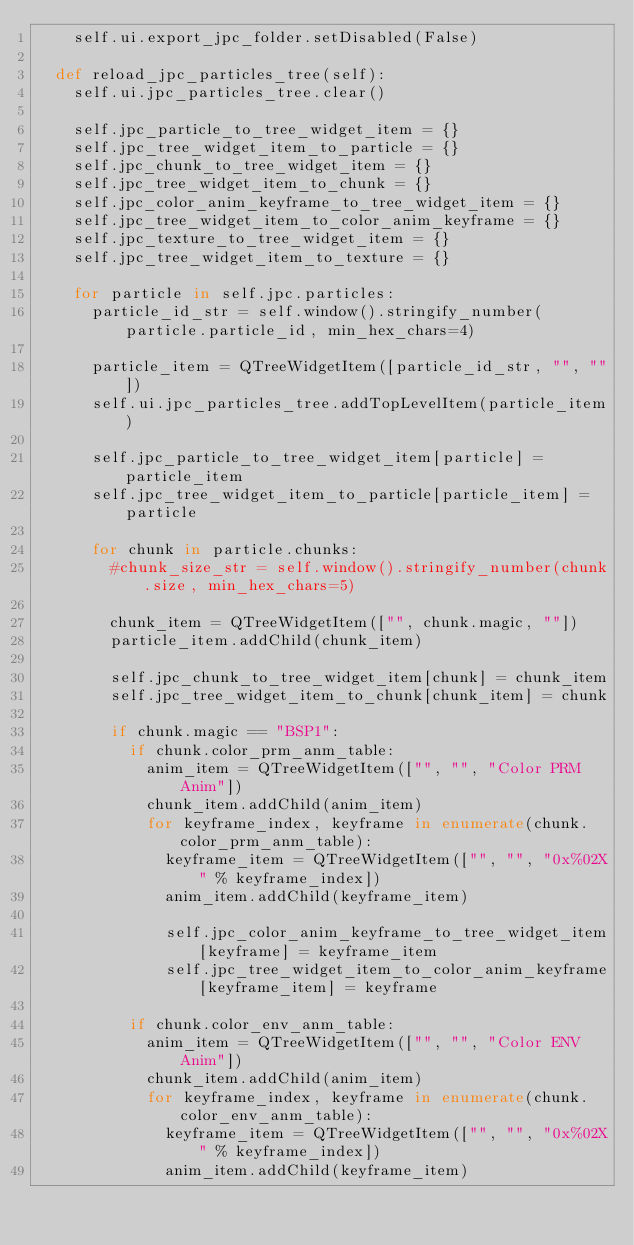<code> <loc_0><loc_0><loc_500><loc_500><_Python_>    self.ui.export_jpc_folder.setDisabled(False)
  
  def reload_jpc_particles_tree(self):
    self.ui.jpc_particles_tree.clear()
    
    self.jpc_particle_to_tree_widget_item = {}
    self.jpc_tree_widget_item_to_particle = {}
    self.jpc_chunk_to_tree_widget_item = {}
    self.jpc_tree_widget_item_to_chunk = {}
    self.jpc_color_anim_keyframe_to_tree_widget_item = {}
    self.jpc_tree_widget_item_to_color_anim_keyframe = {}
    self.jpc_texture_to_tree_widget_item = {}
    self.jpc_tree_widget_item_to_texture = {}
    
    for particle in self.jpc.particles:
      particle_id_str = self.window().stringify_number(particle.particle_id, min_hex_chars=4)
      
      particle_item = QTreeWidgetItem([particle_id_str, "", ""])
      self.ui.jpc_particles_tree.addTopLevelItem(particle_item)
      
      self.jpc_particle_to_tree_widget_item[particle] = particle_item
      self.jpc_tree_widget_item_to_particle[particle_item] = particle
      
      for chunk in particle.chunks:
        #chunk_size_str = self.window().stringify_number(chunk.size, min_hex_chars=5)
        
        chunk_item = QTreeWidgetItem(["", chunk.magic, ""])
        particle_item.addChild(chunk_item)
        
        self.jpc_chunk_to_tree_widget_item[chunk] = chunk_item
        self.jpc_tree_widget_item_to_chunk[chunk_item] = chunk
        
        if chunk.magic == "BSP1":
          if chunk.color_prm_anm_table:
            anim_item = QTreeWidgetItem(["", "", "Color PRM Anim"])
            chunk_item.addChild(anim_item)
            for keyframe_index, keyframe in enumerate(chunk.color_prm_anm_table):
              keyframe_item = QTreeWidgetItem(["", "", "0x%02X" % keyframe_index])
              anim_item.addChild(keyframe_item)
              
              self.jpc_color_anim_keyframe_to_tree_widget_item[keyframe] = keyframe_item
              self.jpc_tree_widget_item_to_color_anim_keyframe[keyframe_item] = keyframe
          
          if chunk.color_env_anm_table:
            anim_item = QTreeWidgetItem(["", "", "Color ENV Anim"])
            chunk_item.addChild(anim_item)
            for keyframe_index, keyframe in enumerate(chunk.color_env_anm_table):
              keyframe_item = QTreeWidgetItem(["", "", "0x%02X" % keyframe_index])
              anim_item.addChild(keyframe_item)
              </code> 